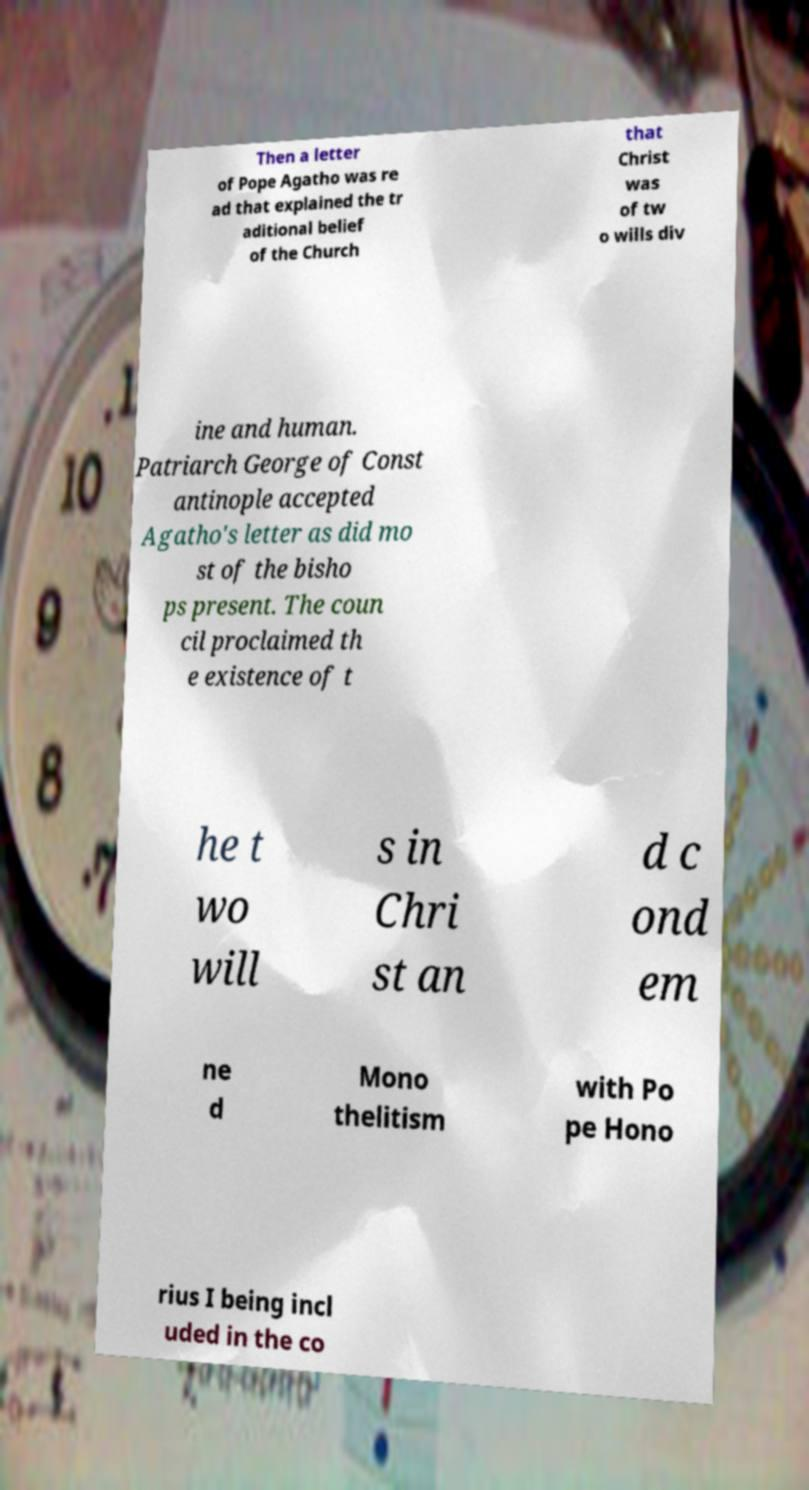I need the written content from this picture converted into text. Can you do that? Then a letter of Pope Agatho was re ad that explained the tr aditional belief of the Church that Christ was of tw o wills div ine and human. Patriarch George of Const antinople accepted Agatho's letter as did mo st of the bisho ps present. The coun cil proclaimed th e existence of t he t wo will s in Chri st an d c ond em ne d Mono thelitism with Po pe Hono rius I being incl uded in the co 